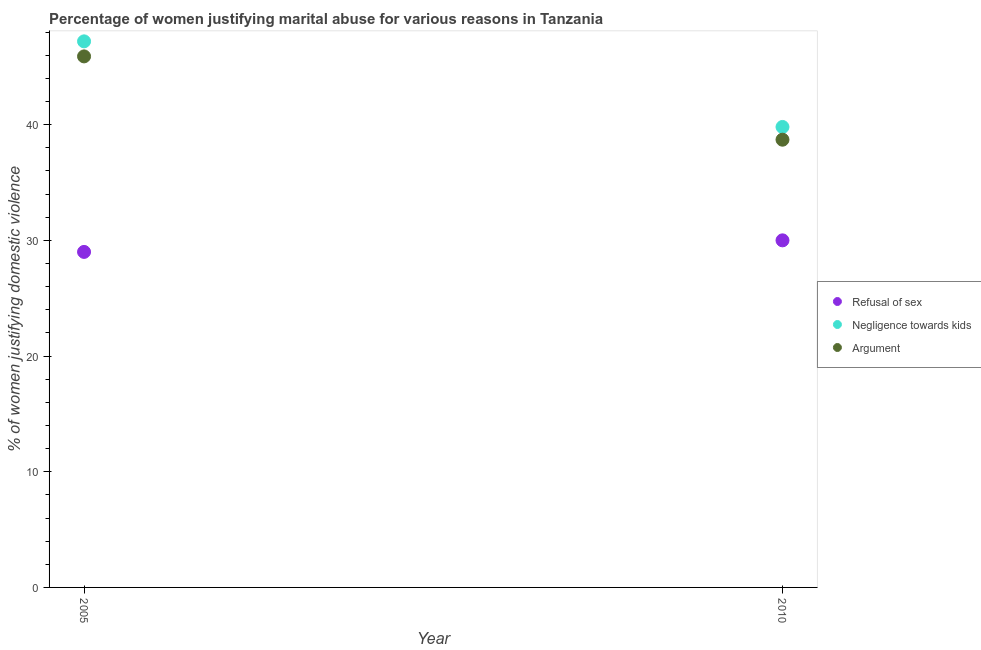How many different coloured dotlines are there?
Your answer should be very brief. 3. Is the number of dotlines equal to the number of legend labels?
Provide a succinct answer. Yes. What is the percentage of women justifying domestic violence due to refusal of sex in 2010?
Your answer should be very brief. 30. Across all years, what is the maximum percentage of women justifying domestic violence due to arguments?
Your response must be concise. 45.9. Across all years, what is the minimum percentage of women justifying domestic violence due to arguments?
Make the answer very short. 38.7. In which year was the percentage of women justifying domestic violence due to arguments maximum?
Provide a succinct answer. 2005. In which year was the percentage of women justifying domestic violence due to negligence towards kids minimum?
Offer a terse response. 2010. What is the total percentage of women justifying domestic violence due to negligence towards kids in the graph?
Keep it short and to the point. 87. What is the difference between the percentage of women justifying domestic violence due to refusal of sex in 2005 and that in 2010?
Provide a short and direct response. -1. What is the difference between the percentage of women justifying domestic violence due to negligence towards kids in 2010 and the percentage of women justifying domestic violence due to refusal of sex in 2005?
Your response must be concise. 10.8. What is the average percentage of women justifying domestic violence due to negligence towards kids per year?
Offer a terse response. 43.5. In the year 2005, what is the difference between the percentage of women justifying domestic violence due to negligence towards kids and percentage of women justifying domestic violence due to arguments?
Your answer should be very brief. 1.3. In how many years, is the percentage of women justifying domestic violence due to negligence towards kids greater than 28 %?
Provide a succinct answer. 2. What is the ratio of the percentage of women justifying domestic violence due to refusal of sex in 2005 to that in 2010?
Ensure brevity in your answer.  0.97. In how many years, is the percentage of women justifying domestic violence due to negligence towards kids greater than the average percentage of women justifying domestic violence due to negligence towards kids taken over all years?
Your answer should be very brief. 1. Is it the case that in every year, the sum of the percentage of women justifying domestic violence due to refusal of sex and percentage of women justifying domestic violence due to negligence towards kids is greater than the percentage of women justifying domestic violence due to arguments?
Your response must be concise. Yes. Does the percentage of women justifying domestic violence due to refusal of sex monotonically increase over the years?
Offer a very short reply. Yes. Is the percentage of women justifying domestic violence due to refusal of sex strictly greater than the percentage of women justifying domestic violence due to negligence towards kids over the years?
Give a very brief answer. No. How many dotlines are there?
Provide a short and direct response. 3. How many years are there in the graph?
Your response must be concise. 2. What is the difference between two consecutive major ticks on the Y-axis?
Your answer should be very brief. 10. Does the graph contain grids?
Make the answer very short. No. What is the title of the graph?
Your answer should be very brief. Percentage of women justifying marital abuse for various reasons in Tanzania. Does "Transport services" appear as one of the legend labels in the graph?
Provide a succinct answer. No. What is the label or title of the Y-axis?
Ensure brevity in your answer.  % of women justifying domestic violence. What is the % of women justifying domestic violence of Refusal of sex in 2005?
Make the answer very short. 29. What is the % of women justifying domestic violence in Negligence towards kids in 2005?
Make the answer very short. 47.2. What is the % of women justifying domestic violence in Argument in 2005?
Keep it short and to the point. 45.9. What is the % of women justifying domestic violence in Refusal of sex in 2010?
Make the answer very short. 30. What is the % of women justifying domestic violence in Negligence towards kids in 2010?
Provide a short and direct response. 39.8. What is the % of women justifying domestic violence in Argument in 2010?
Offer a very short reply. 38.7. Across all years, what is the maximum % of women justifying domestic violence in Refusal of sex?
Make the answer very short. 30. Across all years, what is the maximum % of women justifying domestic violence of Negligence towards kids?
Offer a terse response. 47.2. Across all years, what is the maximum % of women justifying domestic violence in Argument?
Provide a succinct answer. 45.9. Across all years, what is the minimum % of women justifying domestic violence of Negligence towards kids?
Offer a terse response. 39.8. Across all years, what is the minimum % of women justifying domestic violence in Argument?
Make the answer very short. 38.7. What is the total % of women justifying domestic violence in Negligence towards kids in the graph?
Make the answer very short. 87. What is the total % of women justifying domestic violence of Argument in the graph?
Your answer should be very brief. 84.6. What is the difference between the % of women justifying domestic violence in Refusal of sex in 2005 and that in 2010?
Offer a very short reply. -1. What is the difference between the % of women justifying domestic violence of Argument in 2005 and that in 2010?
Your response must be concise. 7.2. What is the difference between the % of women justifying domestic violence in Refusal of sex in 2005 and the % of women justifying domestic violence in Negligence towards kids in 2010?
Provide a short and direct response. -10.8. What is the difference between the % of women justifying domestic violence in Refusal of sex in 2005 and the % of women justifying domestic violence in Argument in 2010?
Your answer should be compact. -9.7. What is the average % of women justifying domestic violence in Refusal of sex per year?
Keep it short and to the point. 29.5. What is the average % of women justifying domestic violence of Negligence towards kids per year?
Provide a succinct answer. 43.5. What is the average % of women justifying domestic violence in Argument per year?
Offer a very short reply. 42.3. In the year 2005, what is the difference between the % of women justifying domestic violence of Refusal of sex and % of women justifying domestic violence of Negligence towards kids?
Ensure brevity in your answer.  -18.2. In the year 2005, what is the difference between the % of women justifying domestic violence in Refusal of sex and % of women justifying domestic violence in Argument?
Your answer should be compact. -16.9. What is the ratio of the % of women justifying domestic violence of Refusal of sex in 2005 to that in 2010?
Your response must be concise. 0.97. What is the ratio of the % of women justifying domestic violence of Negligence towards kids in 2005 to that in 2010?
Your answer should be very brief. 1.19. What is the ratio of the % of women justifying domestic violence of Argument in 2005 to that in 2010?
Your answer should be compact. 1.19. What is the difference between the highest and the second highest % of women justifying domestic violence of Negligence towards kids?
Provide a short and direct response. 7.4. What is the difference between the highest and the second highest % of women justifying domestic violence in Argument?
Your response must be concise. 7.2. What is the difference between the highest and the lowest % of women justifying domestic violence in Refusal of sex?
Provide a short and direct response. 1. What is the difference between the highest and the lowest % of women justifying domestic violence of Negligence towards kids?
Offer a terse response. 7.4. 